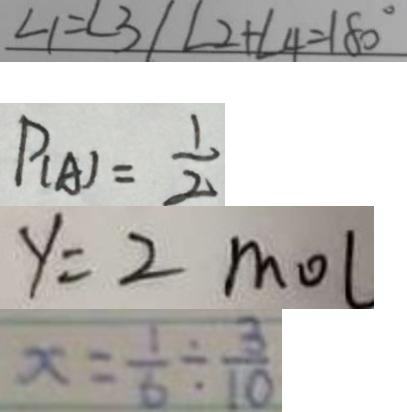<formula> <loc_0><loc_0><loc_500><loc_500>\angle 1 = \angle 3 \vert \angle 2 + \angle 4 = 1 8 0 ^ { \circ } 
 P _ { ( A ) } = \frac { 1 } { 2 } 
 y = 2 m o l 
 x = \frac { 1 } { 6 } \div \frac { 3 } { 1 0 }</formula> 